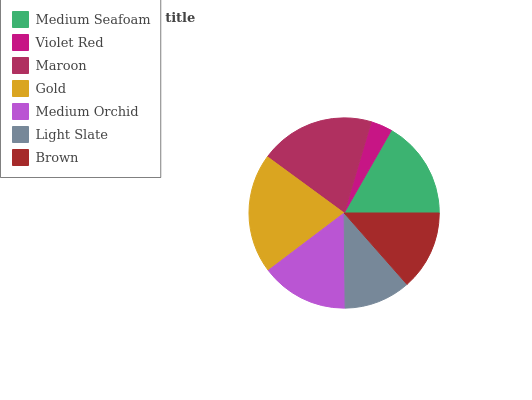Is Violet Red the minimum?
Answer yes or no. Yes. Is Gold the maximum?
Answer yes or no. Yes. Is Maroon the minimum?
Answer yes or no. No. Is Maroon the maximum?
Answer yes or no. No. Is Maroon greater than Violet Red?
Answer yes or no. Yes. Is Violet Red less than Maroon?
Answer yes or no. Yes. Is Violet Red greater than Maroon?
Answer yes or no. No. Is Maroon less than Violet Red?
Answer yes or no. No. Is Medium Orchid the high median?
Answer yes or no. Yes. Is Medium Orchid the low median?
Answer yes or no. Yes. Is Brown the high median?
Answer yes or no. No. Is Gold the low median?
Answer yes or no. No. 